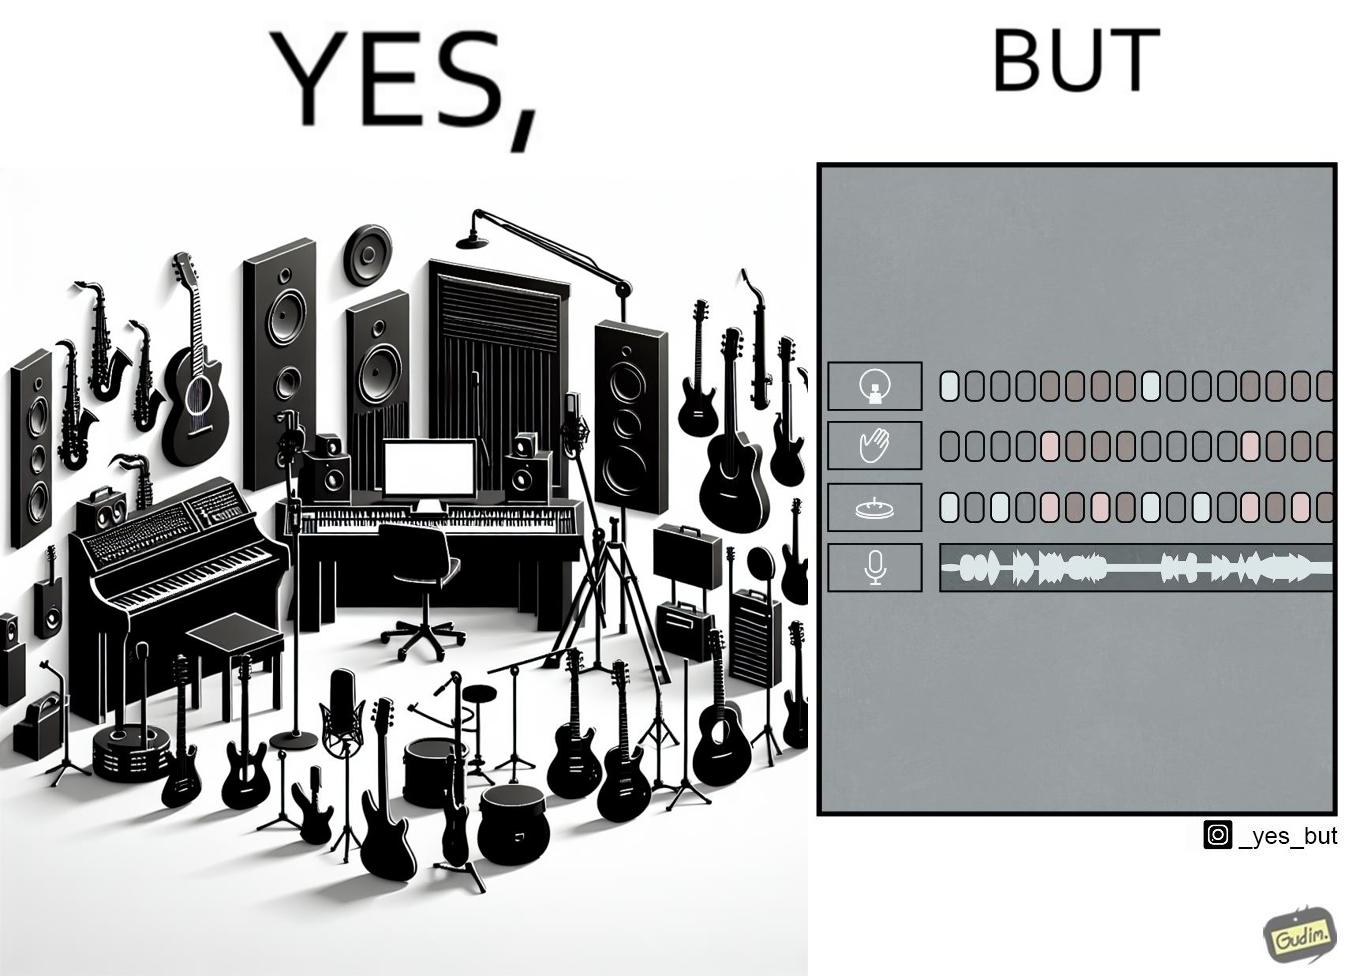Describe what you see in the left and right parts of this image. In the left part of the image: The image shows a music studio with differnt kinds of instruments like guitar and saxophone, piano and recording  to make music. In the right part of the image: The image shows the view of an electornic equipment used to create music. It has buttons to record, play drums and other musical instruments. 